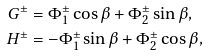<formula> <loc_0><loc_0><loc_500><loc_500>G ^ { \pm } & = \Phi _ { 1 } ^ { \pm } \cos \beta + \Phi _ { 2 } ^ { \pm } \sin \beta , \\ H ^ { \pm } & = - \Phi _ { 1 } ^ { \pm } \sin \beta + \Phi _ { 2 } ^ { \pm } \cos \beta ,</formula> 